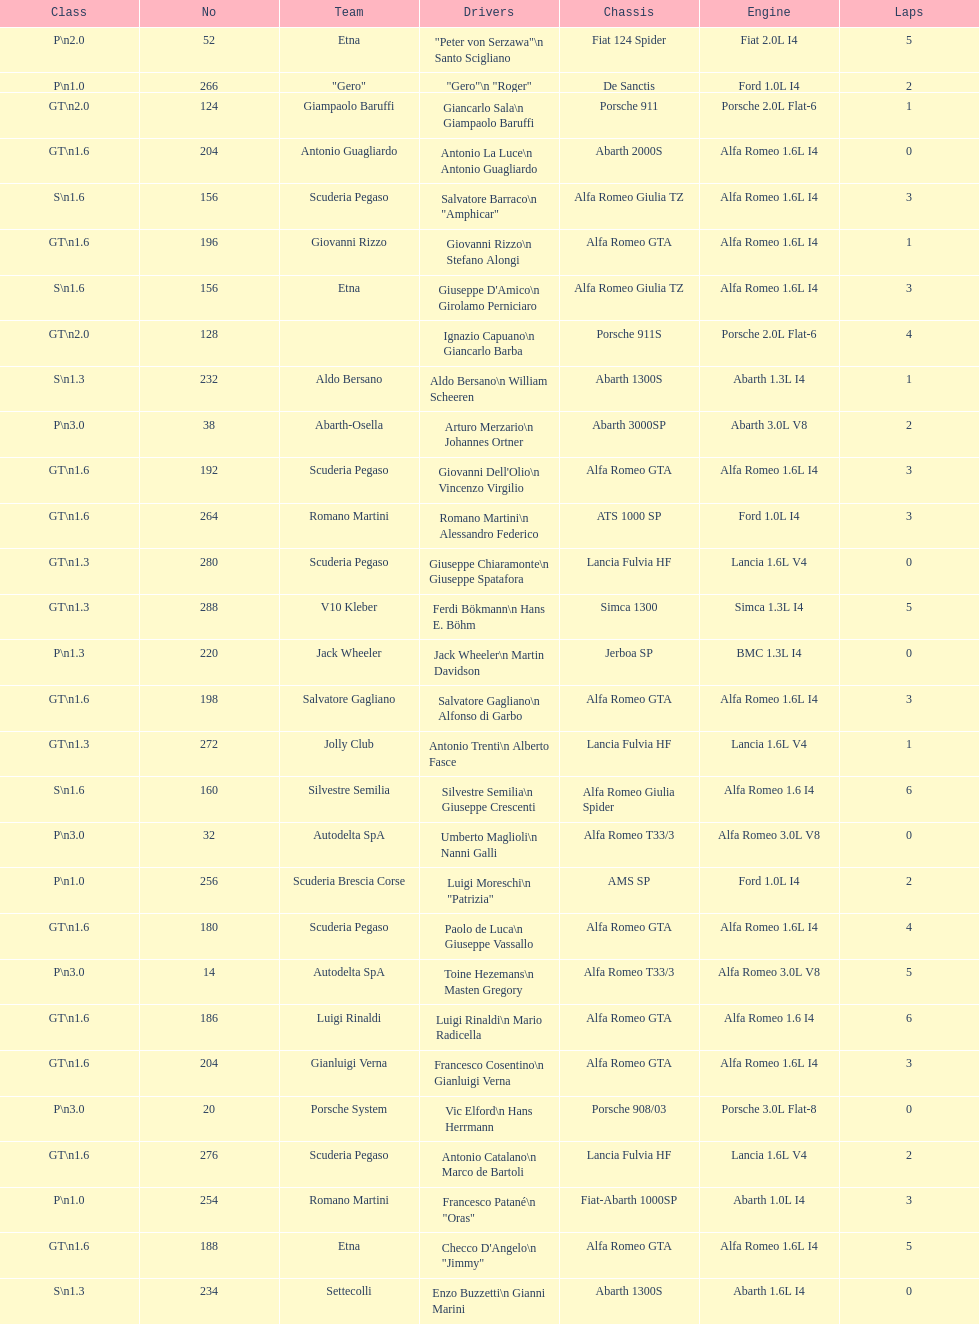If "jimmy" is his nickname, what is his actual full name? Checco D'Angelo. 